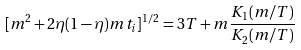Convert formula to latex. <formula><loc_0><loc_0><loc_500><loc_500>[ m ^ { 2 } + 2 \eta ( 1 - \eta ) m t _ { i } ] ^ { 1 / 2 } = 3 T + m \frac { K _ { 1 } ( m / T ) } { K _ { 2 } ( m / T ) }</formula> 